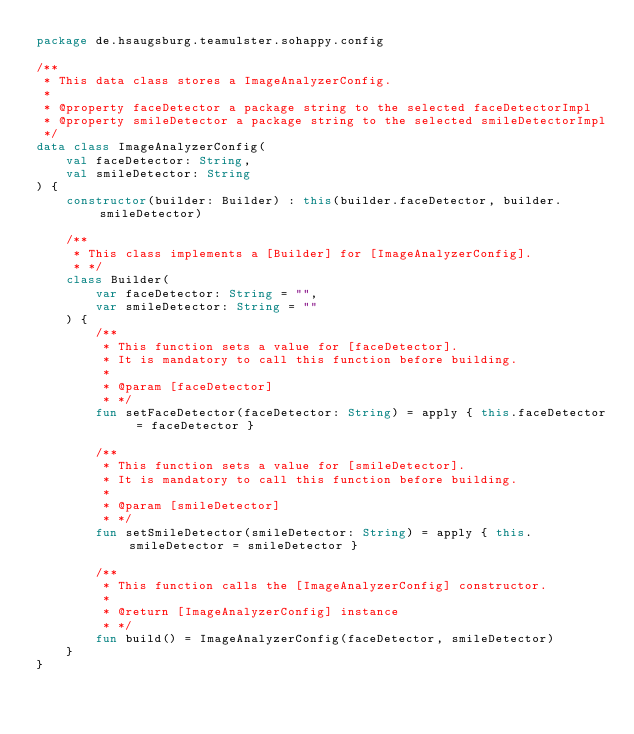Convert code to text. <code><loc_0><loc_0><loc_500><loc_500><_Kotlin_>package de.hsaugsburg.teamulster.sohappy.config

/**
 * This data class stores a ImageAnalyzerConfig.
 *
 * @property faceDetector a package string to the selected faceDetectorImpl
 * @property smileDetector a package string to the selected smileDetectorImpl
 */
data class ImageAnalyzerConfig(
    val faceDetector: String,
    val smileDetector: String
) {
    constructor(builder: Builder) : this(builder.faceDetector, builder.smileDetector)

    /**
     * This class implements a [Builder] for [ImageAnalyzerConfig].
     * */
    class Builder(
        var faceDetector: String = "",
        var smileDetector: String = ""
    ) {
        /**
         * This function sets a value for [faceDetector].
         * It is mandatory to call this function before building.
         *
         * @param [faceDetector]
         * */
        fun setFaceDetector(faceDetector: String) = apply { this.faceDetector = faceDetector }

        /**
         * This function sets a value for [smileDetector].
         * It is mandatory to call this function before building.
         *
         * @param [smileDetector]
         * */
        fun setSmileDetector(smileDetector: String) = apply { this.smileDetector = smileDetector }

        /**
         * This function calls the [ImageAnalyzerConfig] constructor.
         *
         * @return [ImageAnalyzerConfig] instance
         * */
        fun build() = ImageAnalyzerConfig(faceDetector, smileDetector)
    }
}
</code> 